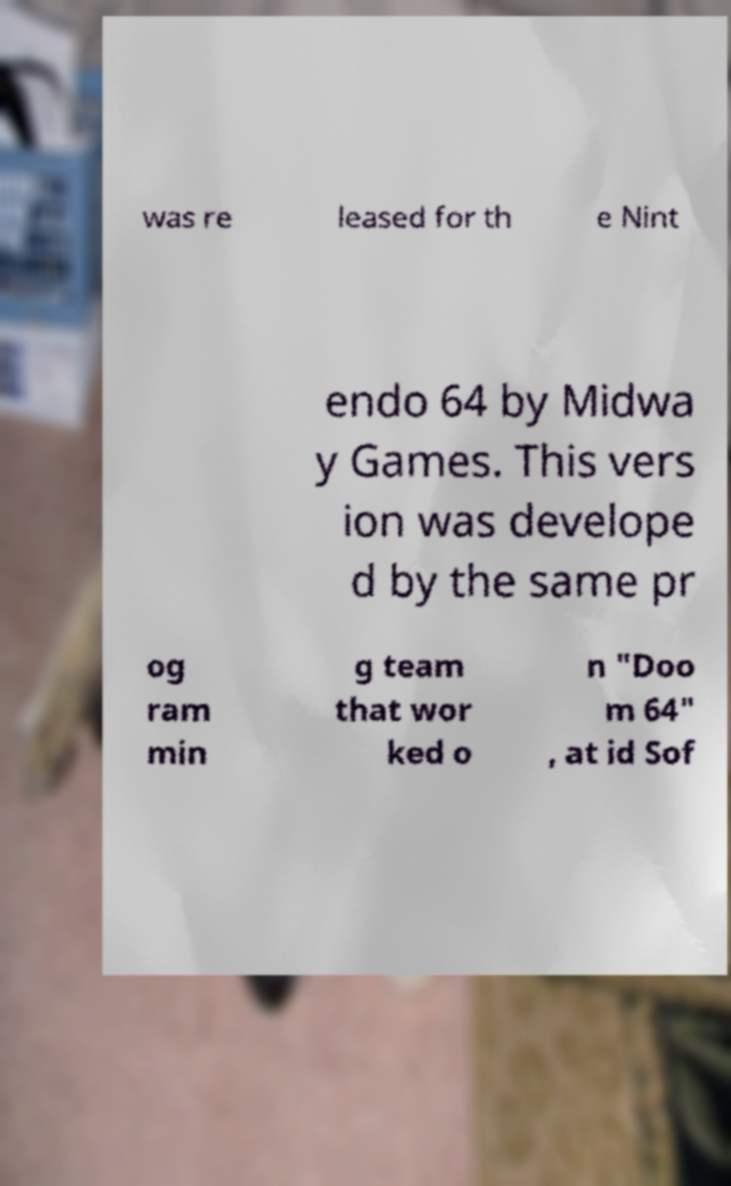There's text embedded in this image that I need extracted. Can you transcribe it verbatim? was re leased for th e Nint endo 64 by Midwa y Games. This vers ion was develope d by the same pr og ram min g team that wor ked o n "Doo m 64" , at id Sof 